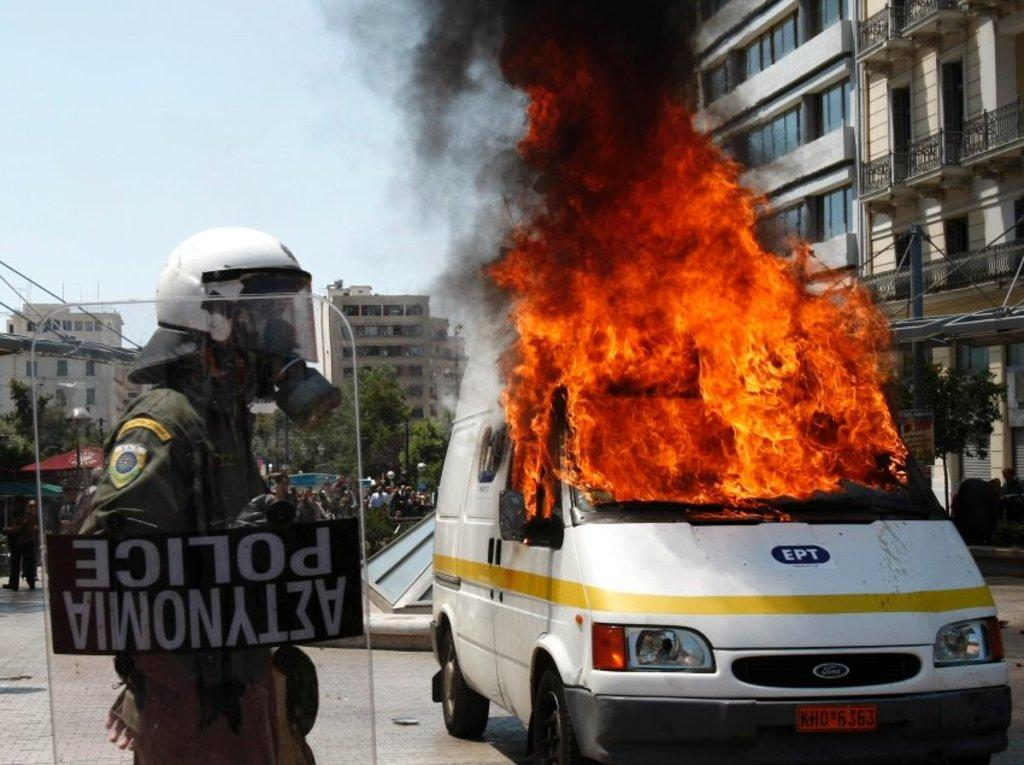What is the occupation of the person standing on the left side of the image? There is a police officer standing on the left side of the image. What is the police officer holding in the image? The police officer is holding a glass protector. What can be seen on the right side of the image? There is a burning vehicle on the right side of the image. What type of structure is visible in the image? There is a building visible in the image. Can you tell me how many frogs are sitting on the burning vehicle in the image? There are no frogs present in the image, and therefore no such activity can be observed. 